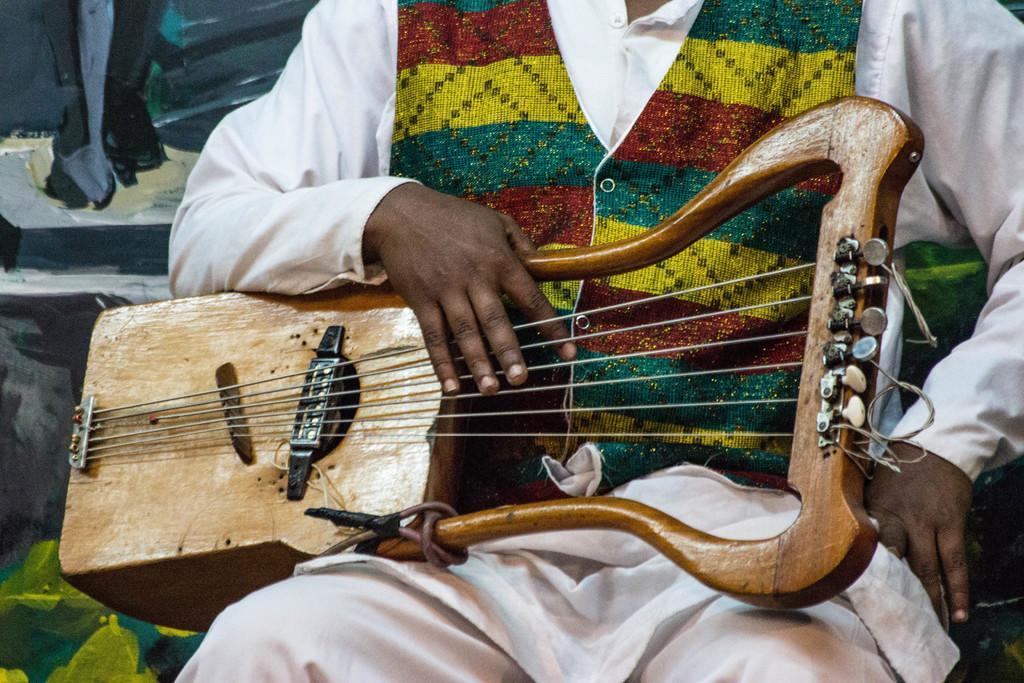Can you describe this image briefly? This picture shows a human seated and playing a musical instrument. 